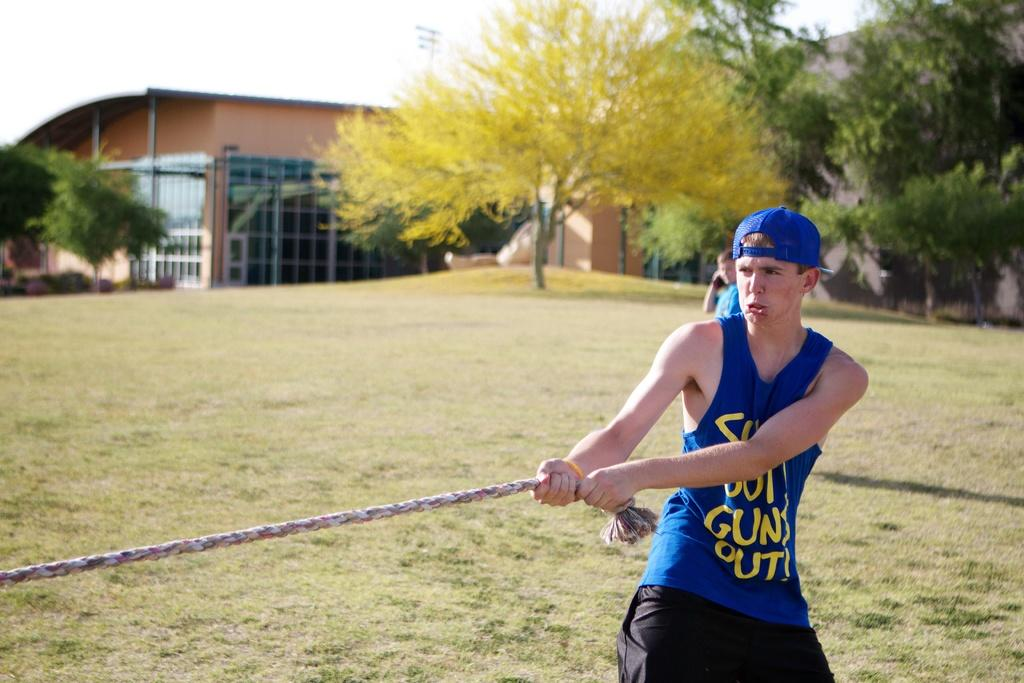<image>
Give a short and clear explanation of the subsequent image. a guy playing tug of war with a slogan on his singlet that ends with "Guns Out". 